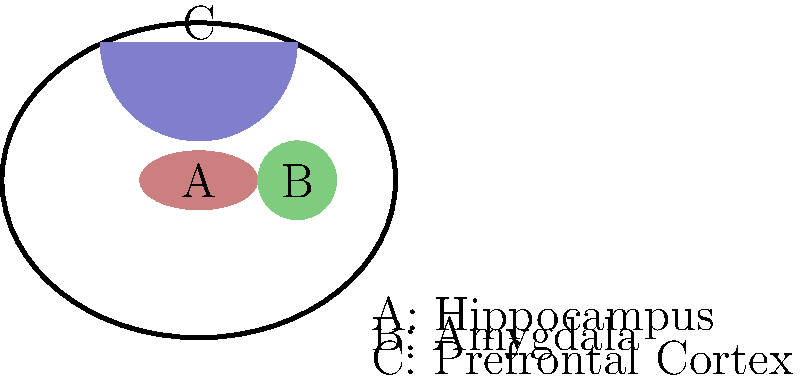Analyze the brain scan image provided. Which of the labeled areas (A, B, or C) is most likely to show reduced activity in war victims experiencing symptoms of post-traumatic stress disorder (PTSD)? Explain your reasoning based on the functions of these brain regions and their role in trauma response. To answer this question, we need to consider the functions of each labeled brain region and their involvement in PTSD:

1. Region A (Hippocampus):
   - Function: Involved in memory formation and consolidation
   - Role in PTSD: Often shows reduced volume and activity in PTSD patients
   - Impact: Contributes to intrusive memories and difficulty forming new non-traumatic memories

2. Region B (Amygdala):
   - Function: Processes emotions, particularly fear and anxiety
   - Role in PTSD: Typically shows hyperactivity in PTSD patients
   - Impact: Leads to heightened fear responses and emotional reactivity

3. Region C (Prefrontal Cortex):
   - Function: Involved in executive functions, emotion regulation, and fear extinction
   - Role in PTSD: Often shows reduced activity in PTSD patients
   - Impact: Results in difficulty regulating emotions and extinguishing fear responses

Among these regions, the prefrontal cortex (C) is most likely to show reduced activity in war victims with PTSD symptoms. This is because:

1. PTSD is characterized by difficulties in emotion regulation and fear extinction, which are primary functions of the prefrontal cortex.
2. Reduced prefrontal cortex activity is consistently observed in PTSD neuroimaging studies.
3. The hippocampus may show reduced volume but not necessarily reduced activity.
4. The amygdala typically shows increased, rather than decreased, activity in PTSD.

Therefore, region C (prefrontal cortex) is the most likely to exhibit reduced activity in war victims experiencing PTSD symptoms.
Answer: C (Prefrontal Cortex) 